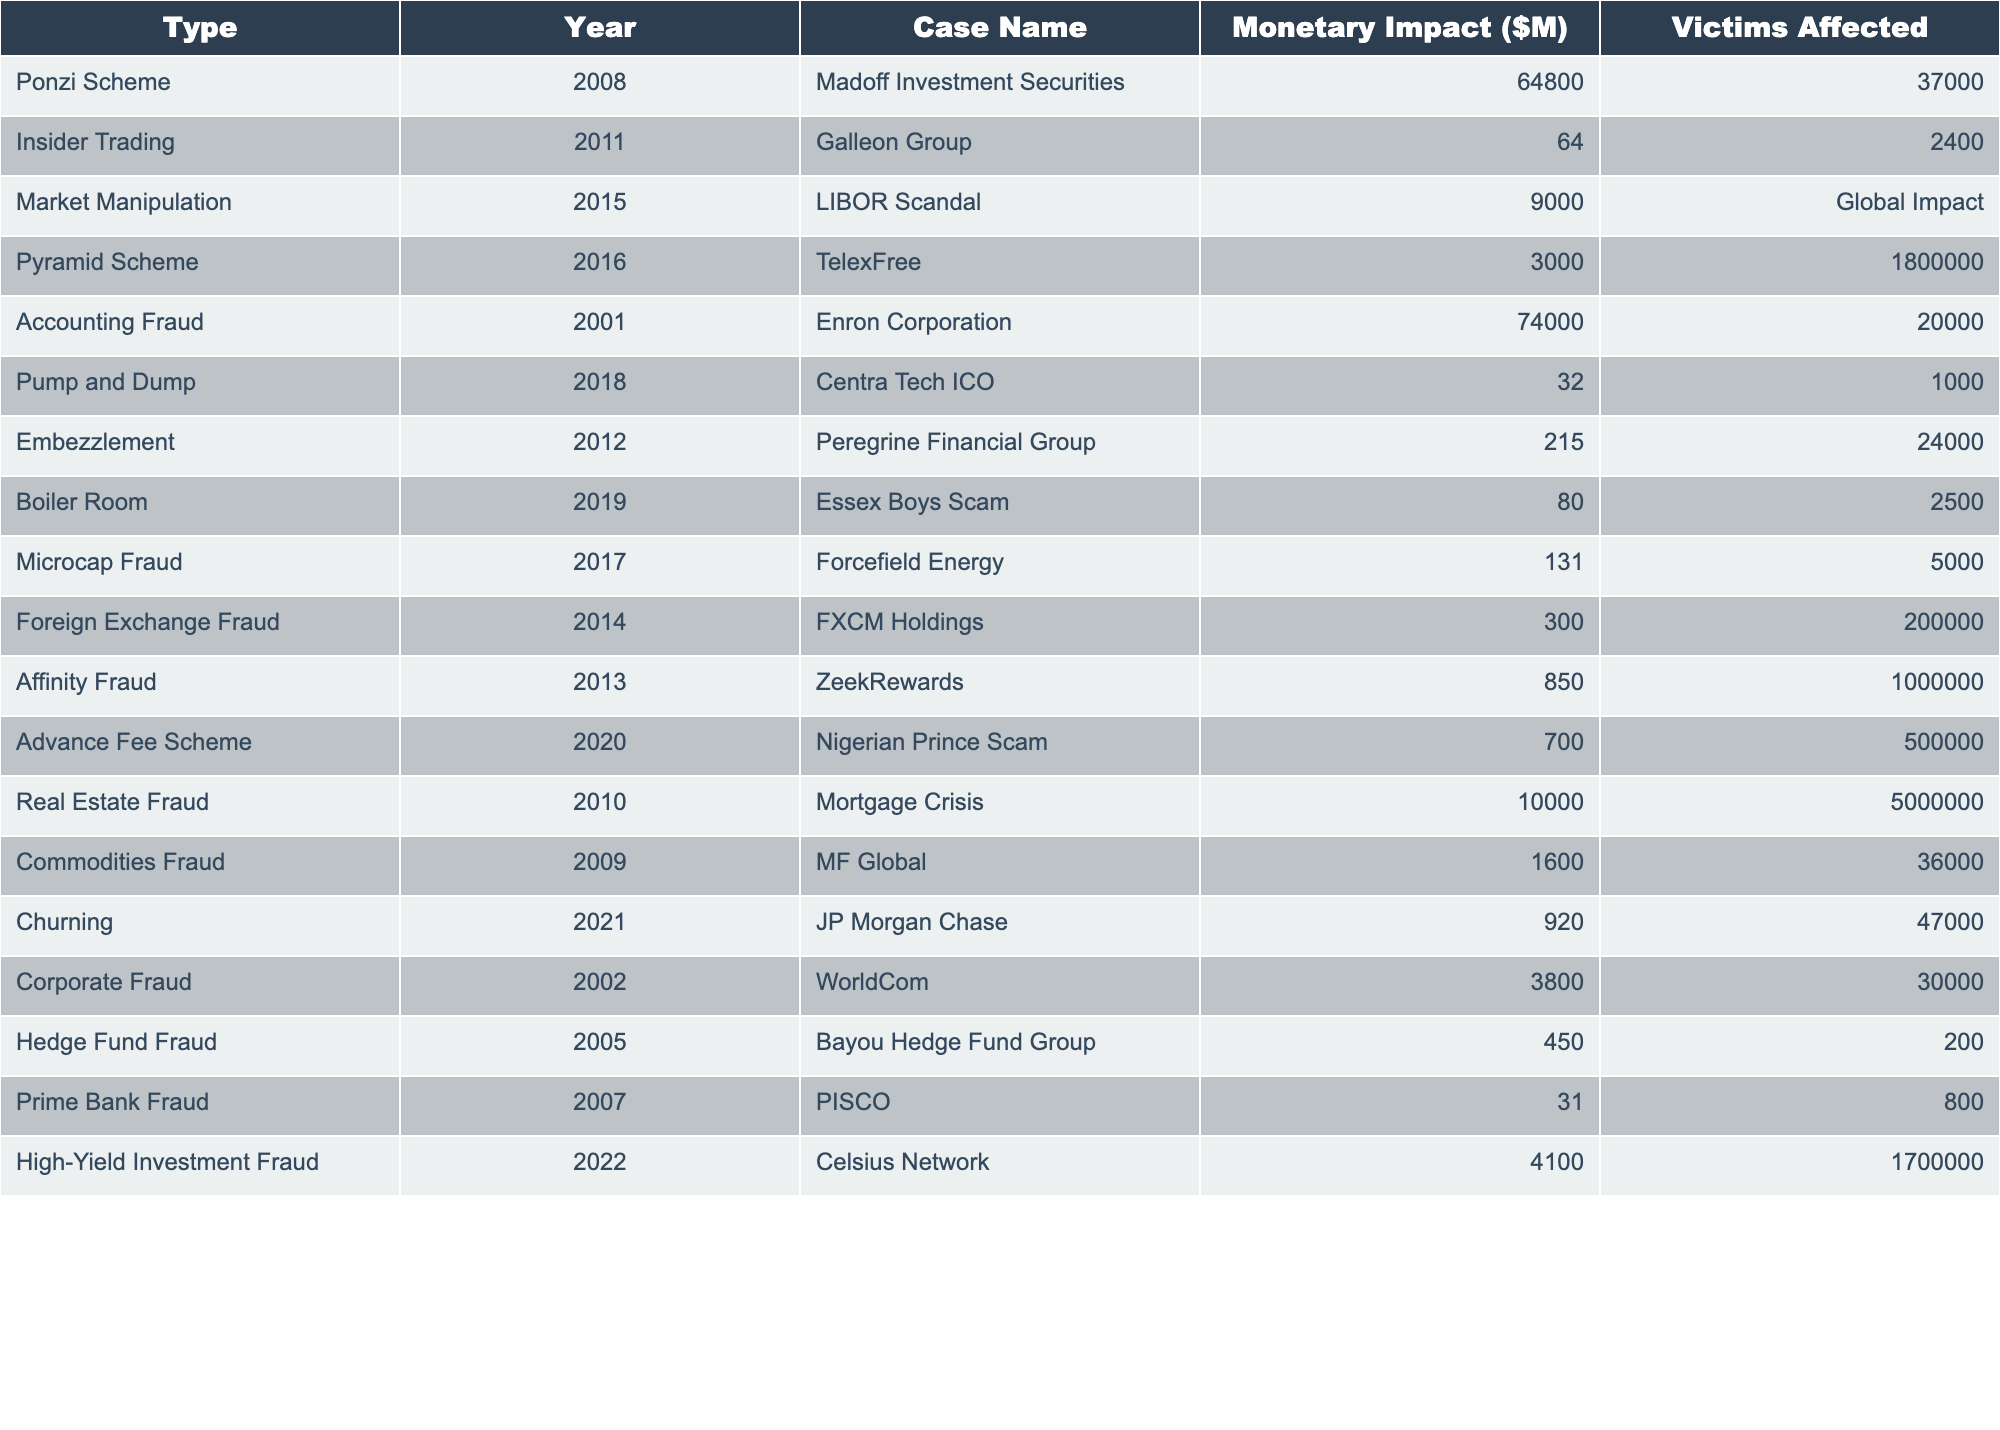What is the monetary impact of the Madoff Investment Securities case? The monetary impact for the Madoff Investment Securities case listed in the table is $64,800 million.
Answer: $64,800 million How many victims were affected by the TelexFree pyramid scheme? The TelexFree pyramid scheme affected 1,800,000 victims according to the table.
Answer: 1,800,000 victims Which type of investment fraud case had the highest monetary impact? The Ponzi Scheme, specifically the Madoff Investment Securities case, has the highest monetary impact at $64,800 million.
Answer: Ponzi Scheme (Madoff Investment Securities) What is the average monetary impact of all the cases listed? The sum of all monetary impacts is $80,236 million from 15 cases, thus the average is $80,236 million / 15 = $5,348 million.
Answer: $5,348 million Was the monetary impact of the Galleon Group case more than $100 million? The monetary impact of the Galleon Group case is $64 million, which is less than $100 million. Therefore, the answer is no.
Answer: No How many cases had a monetary impact greater than $10 million? The cases with a monetary impact greater than $10 million are Madoff Investment Securities, Enron Corporation, LIBOR Scandal, Real Estate Fraud, and a few more, totaling 9 cases.
Answer: 9 cases What is the total monetary impact of all pyramid schemes listed? The total monetary impact of pyramid schemes is the sum of TelexFree ($3,000 million) and the High-Yield Investment Fraud ($4,100 million), which totals $7,100 million.
Answer: $7,100 million Which case affected the most victims? The TelexFree pyramid scheme affected the most victims with 1,800,000 people impacted.
Answer: TelexFree (1,800,000 victims) Is it true that the Centra Tech ICO case had a monetary impact less than $50 million? The Centra Tech ICO case had a monetary impact of $32 million, which is indeed less than $50 million, making the statement true.
Answer: True What is the difference in monetary impact between the Enron and WorldCom cases? The monetary impact of the Enron case is $74,000 million and WorldCom is $3,800 million. The difference is $74,000 million - $3,800 million = $70,200 million.
Answer: $70,200 million How many cases in total were reported in the year 2012? According to the table, there are 2 cases reported in 2012, which are the Peregrine Financial Group and another insider trading case.
Answer: 2 cases 